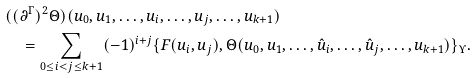<formula> <loc_0><loc_0><loc_500><loc_500>& ( ( \partial ^ { \Gamma } ) ^ { 2 } \Theta ) ( u _ { 0 } , u _ { 1 } , \dots , u _ { i } , \dots , u _ { j } , \dots , u _ { k + 1 } ) \\ & \quad = \sum _ { 0 \leq i < j \leq k + 1 } ( - 1 ) ^ { i + j } \{ F ( u _ { i } , u _ { j } ) , \Theta ( u _ { 0 } , u _ { 1 } , \dots , \hat { u } _ { i } , \dots , \hat { u } _ { j } , \dots , u _ { k + 1 } ) \} _ { \Upsilon } .</formula> 